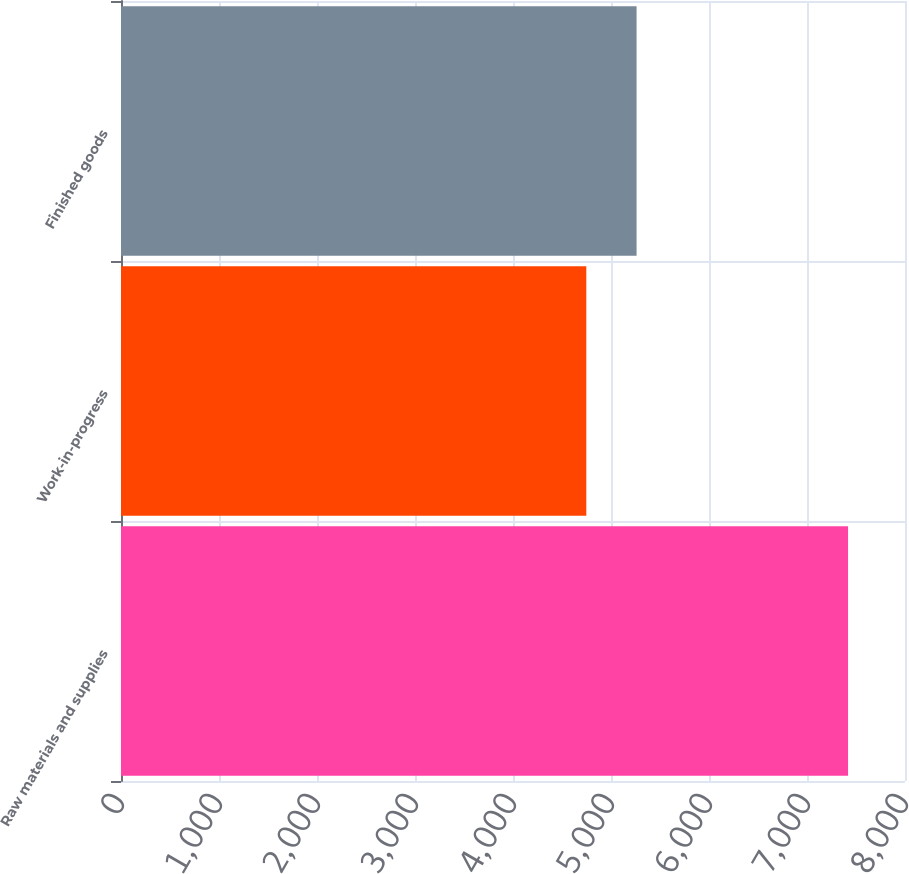<chart> <loc_0><loc_0><loc_500><loc_500><bar_chart><fcel>Raw materials and supplies<fcel>Work-in-progress<fcel>Finished goods<nl><fcel>7419<fcel>4748<fcel>5261<nl></chart> 